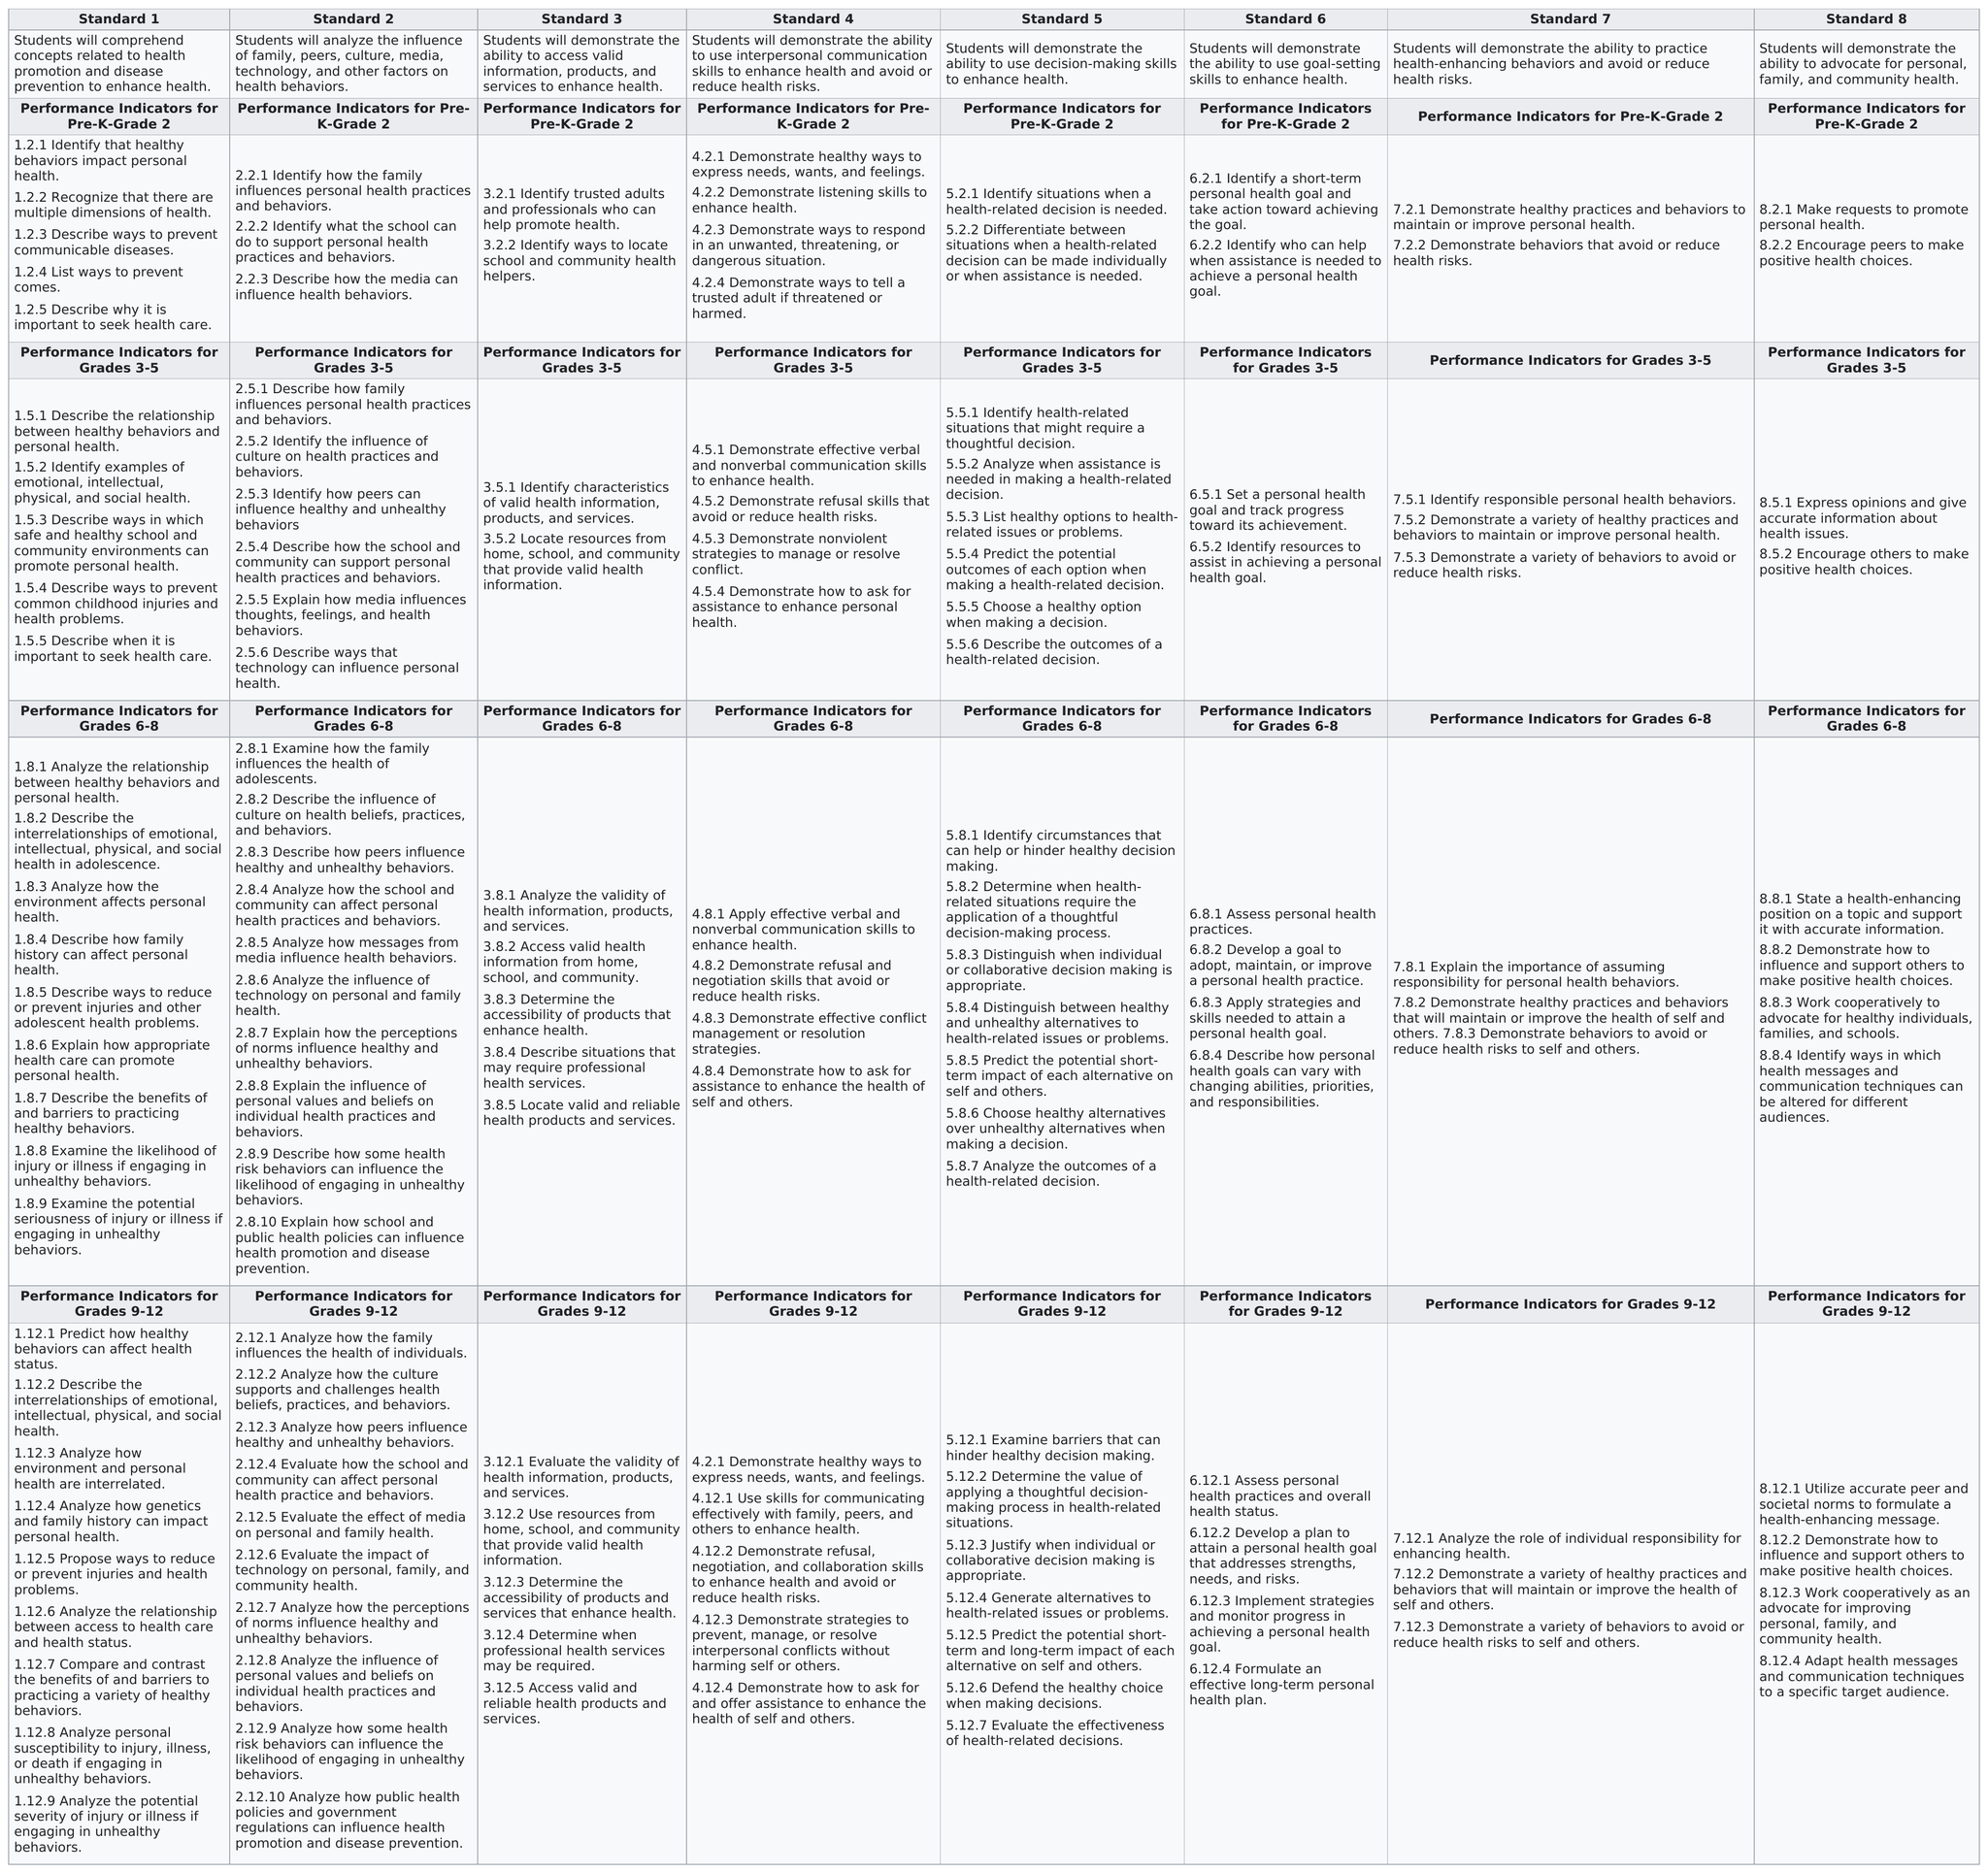Highlight a few significant elements in this photo. The total number of standards is eight. There are two performance indicators for Standard 3 for grades 3-5. The standard with the most criteria written for performance indicators for grades 9-12 is Standard 2. 